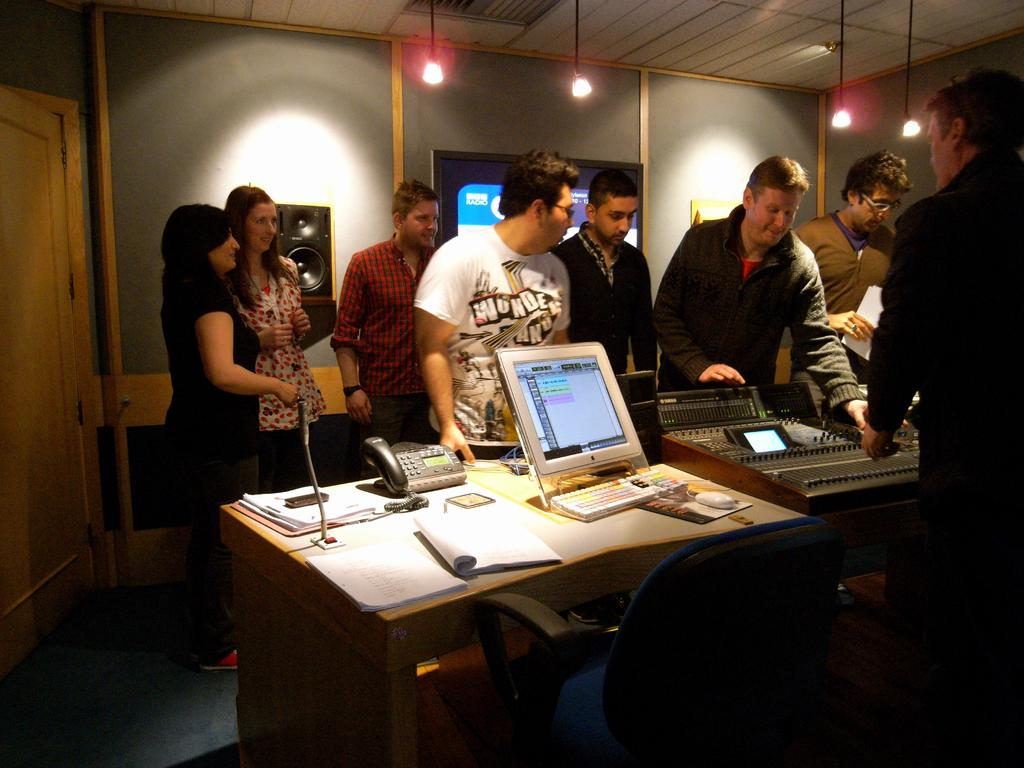What are the people in the image doing? The people in the image are standing. What is in front of the people? There is a table in front of the people. What electronic devices are on the table? There is a monitor and a telephone on the table. What else can be found on the table? There are other instruments on the table. What type of hammer is being used to fix the heart in the image? There is no hammer or heart present in the image. 